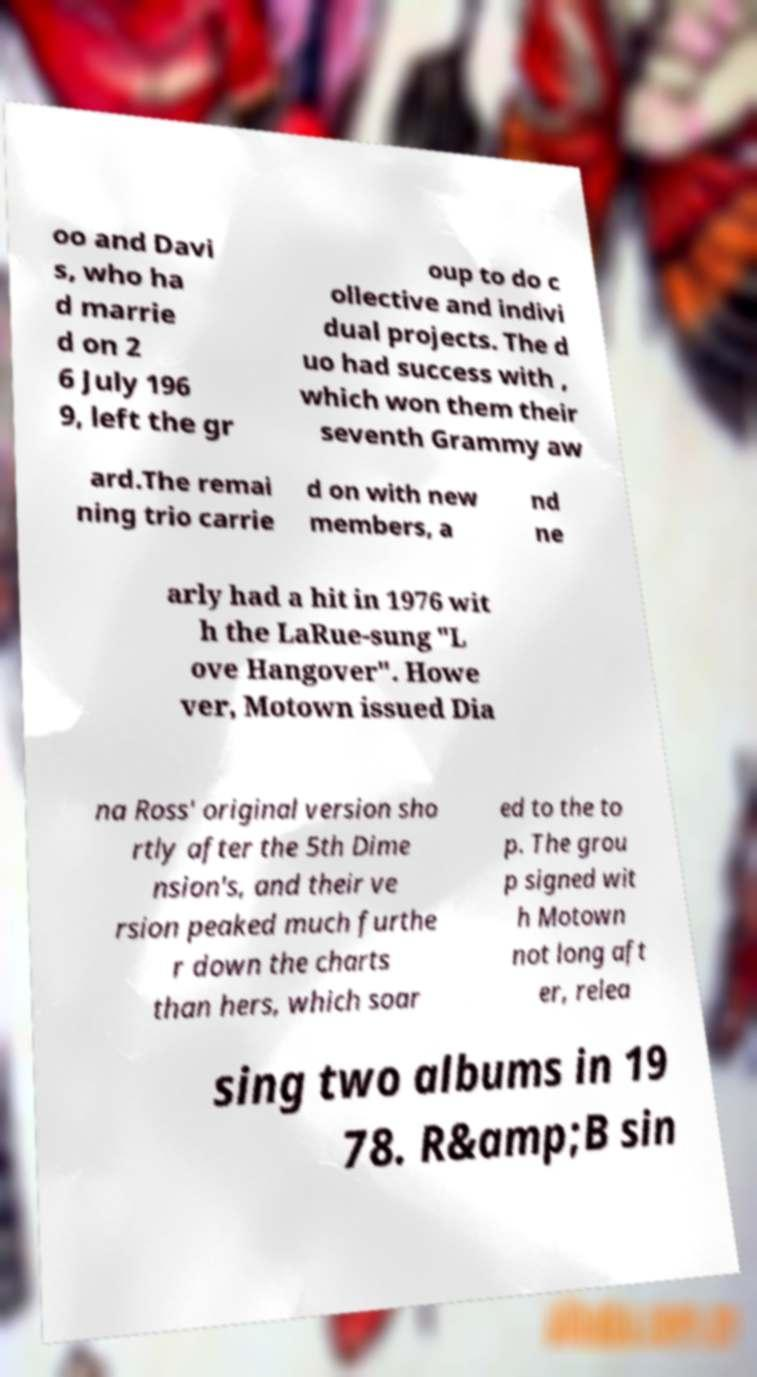For documentation purposes, I need the text within this image transcribed. Could you provide that? oo and Davi s, who ha d marrie d on 2 6 July 196 9, left the gr oup to do c ollective and indivi dual projects. The d uo had success with , which won them their seventh Grammy aw ard.The remai ning trio carrie d on with new members, a nd ne arly had a hit in 1976 wit h the LaRue-sung "L ove Hangover". Howe ver, Motown issued Dia na Ross' original version sho rtly after the 5th Dime nsion's, and their ve rsion peaked much furthe r down the charts than hers, which soar ed to the to p. The grou p signed wit h Motown not long aft er, relea sing two albums in 19 78. R&amp;B sin 